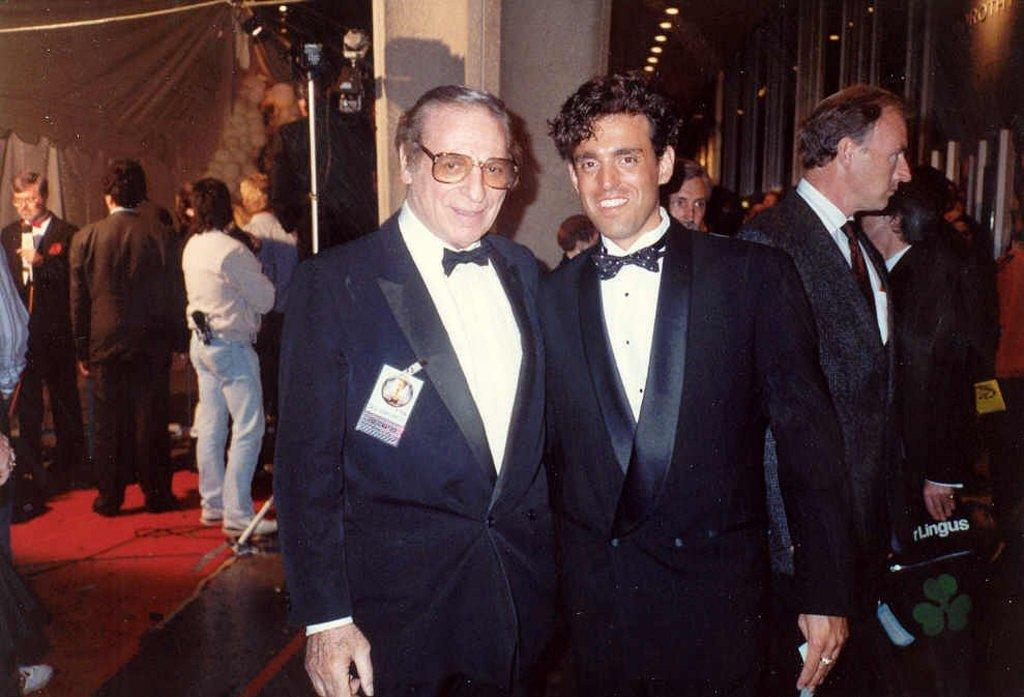How many people are smiling in the image? There are two persons standing and smiling in the image. What can be seen in the background of the image? There is a group of people standing in the background of the image. What is illuminating the scene in the image? There are lights visible in the image. Can you describe any other items present in the image? There are other items present in the image, but their specific nature is not mentioned in the provided facts. Reasoning: Let' Let's think step by step in order to produce the conversation. We start by identifying the main subjects in the image, which are the two persons standing and smiling. Then, we expand the conversation to include the group of people in the background and the lights visible in the image. We avoid asking questions about the specific nature of the other items present in the image, as this information is not provided in the facts. Absurd Question/Answer: What is the weight of the fifth person in the image? There is no mention of a fifth person in the image, so their weight cannot be determined. 